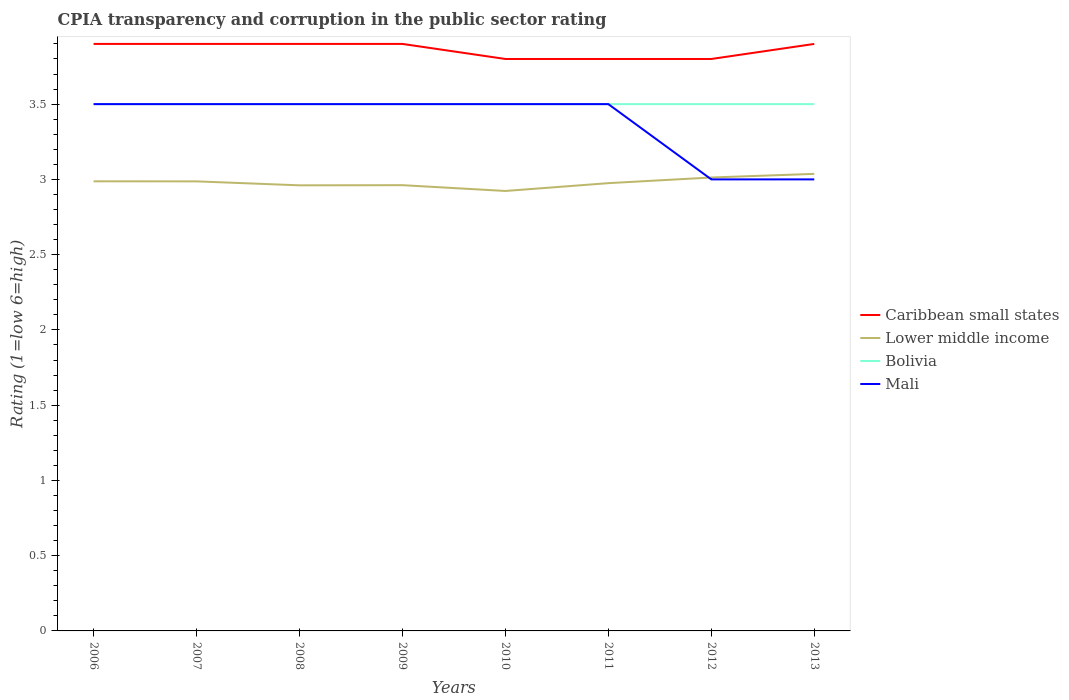How many different coloured lines are there?
Provide a short and direct response. 4. Is the CPIA rating in Mali strictly greater than the CPIA rating in Bolivia over the years?
Give a very brief answer. No. How many lines are there?
Provide a short and direct response. 4. Are the values on the major ticks of Y-axis written in scientific E-notation?
Offer a terse response. No. Does the graph contain any zero values?
Your answer should be very brief. No. Where does the legend appear in the graph?
Offer a very short reply. Center right. How many legend labels are there?
Keep it short and to the point. 4. How are the legend labels stacked?
Provide a short and direct response. Vertical. What is the title of the graph?
Provide a short and direct response. CPIA transparency and corruption in the public sector rating. Does "Papua New Guinea" appear as one of the legend labels in the graph?
Make the answer very short. No. What is the Rating (1=low 6=high) of Lower middle income in 2006?
Keep it short and to the point. 2.99. What is the Rating (1=low 6=high) of Mali in 2006?
Give a very brief answer. 3.5. What is the Rating (1=low 6=high) of Caribbean small states in 2007?
Offer a terse response. 3.9. What is the Rating (1=low 6=high) of Lower middle income in 2007?
Offer a terse response. 2.99. What is the Rating (1=low 6=high) of Bolivia in 2007?
Your response must be concise. 3.5. What is the Rating (1=low 6=high) in Caribbean small states in 2008?
Provide a succinct answer. 3.9. What is the Rating (1=low 6=high) of Lower middle income in 2008?
Offer a terse response. 2.96. What is the Rating (1=low 6=high) of Bolivia in 2008?
Your answer should be compact. 3.5. What is the Rating (1=low 6=high) in Caribbean small states in 2009?
Your answer should be compact. 3.9. What is the Rating (1=low 6=high) of Lower middle income in 2009?
Provide a short and direct response. 2.96. What is the Rating (1=low 6=high) in Bolivia in 2009?
Keep it short and to the point. 3.5. What is the Rating (1=low 6=high) in Lower middle income in 2010?
Your answer should be very brief. 2.92. What is the Rating (1=low 6=high) of Mali in 2010?
Provide a short and direct response. 3.5. What is the Rating (1=low 6=high) of Lower middle income in 2011?
Offer a terse response. 2.98. What is the Rating (1=low 6=high) of Bolivia in 2011?
Your answer should be compact. 3.5. What is the Rating (1=low 6=high) in Lower middle income in 2012?
Make the answer very short. 3.01. What is the Rating (1=low 6=high) of Bolivia in 2012?
Your answer should be compact. 3.5. What is the Rating (1=low 6=high) in Lower middle income in 2013?
Offer a very short reply. 3.04. What is the Rating (1=low 6=high) in Mali in 2013?
Provide a succinct answer. 3. Across all years, what is the maximum Rating (1=low 6=high) in Lower middle income?
Your answer should be very brief. 3.04. Across all years, what is the maximum Rating (1=low 6=high) of Bolivia?
Offer a very short reply. 3.5. Across all years, what is the minimum Rating (1=low 6=high) of Caribbean small states?
Provide a short and direct response. 3.8. Across all years, what is the minimum Rating (1=low 6=high) of Lower middle income?
Keep it short and to the point. 2.92. Across all years, what is the minimum Rating (1=low 6=high) in Mali?
Offer a very short reply. 3. What is the total Rating (1=low 6=high) of Caribbean small states in the graph?
Your answer should be very brief. 30.9. What is the total Rating (1=low 6=high) in Lower middle income in the graph?
Your response must be concise. 23.84. What is the difference between the Rating (1=low 6=high) of Caribbean small states in 2006 and that in 2007?
Give a very brief answer. 0. What is the difference between the Rating (1=low 6=high) of Lower middle income in 2006 and that in 2008?
Make the answer very short. 0.03. What is the difference between the Rating (1=low 6=high) in Caribbean small states in 2006 and that in 2009?
Your answer should be compact. 0. What is the difference between the Rating (1=low 6=high) of Lower middle income in 2006 and that in 2009?
Your answer should be compact. 0.03. What is the difference between the Rating (1=low 6=high) of Lower middle income in 2006 and that in 2010?
Offer a terse response. 0.06. What is the difference between the Rating (1=low 6=high) in Bolivia in 2006 and that in 2010?
Make the answer very short. 0. What is the difference between the Rating (1=low 6=high) in Mali in 2006 and that in 2010?
Keep it short and to the point. 0. What is the difference between the Rating (1=low 6=high) in Caribbean small states in 2006 and that in 2011?
Ensure brevity in your answer.  0.1. What is the difference between the Rating (1=low 6=high) of Lower middle income in 2006 and that in 2011?
Make the answer very short. 0.01. What is the difference between the Rating (1=low 6=high) of Lower middle income in 2006 and that in 2012?
Ensure brevity in your answer.  -0.03. What is the difference between the Rating (1=low 6=high) in Bolivia in 2006 and that in 2012?
Make the answer very short. 0. What is the difference between the Rating (1=low 6=high) of Lower middle income in 2006 and that in 2013?
Give a very brief answer. -0.05. What is the difference between the Rating (1=low 6=high) of Bolivia in 2006 and that in 2013?
Keep it short and to the point. 0. What is the difference between the Rating (1=low 6=high) of Mali in 2006 and that in 2013?
Offer a very short reply. 0.5. What is the difference between the Rating (1=low 6=high) of Caribbean small states in 2007 and that in 2008?
Give a very brief answer. 0. What is the difference between the Rating (1=low 6=high) in Lower middle income in 2007 and that in 2008?
Your answer should be very brief. 0.03. What is the difference between the Rating (1=low 6=high) in Bolivia in 2007 and that in 2008?
Your answer should be very brief. 0. What is the difference between the Rating (1=low 6=high) in Mali in 2007 and that in 2008?
Ensure brevity in your answer.  0. What is the difference between the Rating (1=low 6=high) in Lower middle income in 2007 and that in 2009?
Your answer should be compact. 0.03. What is the difference between the Rating (1=low 6=high) of Lower middle income in 2007 and that in 2010?
Keep it short and to the point. 0.06. What is the difference between the Rating (1=low 6=high) in Lower middle income in 2007 and that in 2011?
Provide a short and direct response. 0.01. What is the difference between the Rating (1=low 6=high) in Bolivia in 2007 and that in 2011?
Provide a short and direct response. 0. What is the difference between the Rating (1=low 6=high) in Mali in 2007 and that in 2011?
Ensure brevity in your answer.  0. What is the difference between the Rating (1=low 6=high) in Caribbean small states in 2007 and that in 2012?
Make the answer very short. 0.1. What is the difference between the Rating (1=low 6=high) of Lower middle income in 2007 and that in 2012?
Make the answer very short. -0.03. What is the difference between the Rating (1=low 6=high) of Bolivia in 2007 and that in 2012?
Provide a short and direct response. 0. What is the difference between the Rating (1=low 6=high) in Mali in 2007 and that in 2012?
Ensure brevity in your answer.  0.5. What is the difference between the Rating (1=low 6=high) of Lower middle income in 2007 and that in 2013?
Your answer should be very brief. -0.05. What is the difference between the Rating (1=low 6=high) in Lower middle income in 2008 and that in 2009?
Your answer should be compact. -0. What is the difference between the Rating (1=low 6=high) of Bolivia in 2008 and that in 2009?
Your answer should be compact. 0. What is the difference between the Rating (1=low 6=high) of Mali in 2008 and that in 2009?
Offer a terse response. 0. What is the difference between the Rating (1=low 6=high) in Caribbean small states in 2008 and that in 2010?
Provide a succinct answer. 0.1. What is the difference between the Rating (1=low 6=high) of Lower middle income in 2008 and that in 2010?
Offer a very short reply. 0.04. What is the difference between the Rating (1=low 6=high) of Bolivia in 2008 and that in 2010?
Your response must be concise. 0. What is the difference between the Rating (1=low 6=high) in Lower middle income in 2008 and that in 2011?
Offer a very short reply. -0.01. What is the difference between the Rating (1=low 6=high) in Caribbean small states in 2008 and that in 2012?
Make the answer very short. 0.1. What is the difference between the Rating (1=low 6=high) in Lower middle income in 2008 and that in 2012?
Ensure brevity in your answer.  -0.05. What is the difference between the Rating (1=low 6=high) of Mali in 2008 and that in 2012?
Your answer should be compact. 0.5. What is the difference between the Rating (1=low 6=high) of Caribbean small states in 2008 and that in 2013?
Keep it short and to the point. 0. What is the difference between the Rating (1=low 6=high) in Lower middle income in 2008 and that in 2013?
Provide a short and direct response. -0.08. What is the difference between the Rating (1=low 6=high) of Mali in 2008 and that in 2013?
Keep it short and to the point. 0.5. What is the difference between the Rating (1=low 6=high) in Lower middle income in 2009 and that in 2010?
Your answer should be compact. 0.04. What is the difference between the Rating (1=low 6=high) in Caribbean small states in 2009 and that in 2011?
Give a very brief answer. 0.1. What is the difference between the Rating (1=low 6=high) of Lower middle income in 2009 and that in 2011?
Your answer should be very brief. -0.01. What is the difference between the Rating (1=low 6=high) in Bolivia in 2009 and that in 2011?
Provide a succinct answer. 0. What is the difference between the Rating (1=low 6=high) in Mali in 2009 and that in 2011?
Your response must be concise. 0. What is the difference between the Rating (1=low 6=high) of Lower middle income in 2009 and that in 2012?
Your answer should be compact. -0.05. What is the difference between the Rating (1=low 6=high) of Bolivia in 2009 and that in 2012?
Your answer should be compact. 0. What is the difference between the Rating (1=low 6=high) of Caribbean small states in 2009 and that in 2013?
Your answer should be very brief. 0. What is the difference between the Rating (1=low 6=high) of Lower middle income in 2009 and that in 2013?
Give a very brief answer. -0.07. What is the difference between the Rating (1=low 6=high) of Bolivia in 2009 and that in 2013?
Provide a short and direct response. 0. What is the difference between the Rating (1=low 6=high) in Mali in 2009 and that in 2013?
Your response must be concise. 0.5. What is the difference between the Rating (1=low 6=high) in Caribbean small states in 2010 and that in 2011?
Your answer should be very brief. 0. What is the difference between the Rating (1=low 6=high) of Lower middle income in 2010 and that in 2011?
Your response must be concise. -0.05. What is the difference between the Rating (1=low 6=high) in Bolivia in 2010 and that in 2011?
Your answer should be compact. 0. What is the difference between the Rating (1=low 6=high) in Lower middle income in 2010 and that in 2012?
Offer a terse response. -0.09. What is the difference between the Rating (1=low 6=high) of Bolivia in 2010 and that in 2012?
Make the answer very short. 0. What is the difference between the Rating (1=low 6=high) in Lower middle income in 2010 and that in 2013?
Provide a short and direct response. -0.11. What is the difference between the Rating (1=low 6=high) in Mali in 2010 and that in 2013?
Give a very brief answer. 0.5. What is the difference between the Rating (1=low 6=high) in Caribbean small states in 2011 and that in 2012?
Make the answer very short. 0. What is the difference between the Rating (1=low 6=high) in Lower middle income in 2011 and that in 2012?
Provide a short and direct response. -0.04. What is the difference between the Rating (1=low 6=high) of Bolivia in 2011 and that in 2012?
Provide a succinct answer. 0. What is the difference between the Rating (1=low 6=high) of Lower middle income in 2011 and that in 2013?
Ensure brevity in your answer.  -0.06. What is the difference between the Rating (1=low 6=high) in Caribbean small states in 2012 and that in 2013?
Your response must be concise. -0.1. What is the difference between the Rating (1=low 6=high) of Lower middle income in 2012 and that in 2013?
Make the answer very short. -0.02. What is the difference between the Rating (1=low 6=high) in Mali in 2012 and that in 2013?
Your answer should be compact. 0. What is the difference between the Rating (1=low 6=high) of Caribbean small states in 2006 and the Rating (1=low 6=high) of Lower middle income in 2007?
Make the answer very short. 0.91. What is the difference between the Rating (1=low 6=high) of Caribbean small states in 2006 and the Rating (1=low 6=high) of Bolivia in 2007?
Offer a terse response. 0.4. What is the difference between the Rating (1=low 6=high) of Lower middle income in 2006 and the Rating (1=low 6=high) of Bolivia in 2007?
Your answer should be very brief. -0.51. What is the difference between the Rating (1=low 6=high) in Lower middle income in 2006 and the Rating (1=low 6=high) in Mali in 2007?
Make the answer very short. -0.51. What is the difference between the Rating (1=low 6=high) of Bolivia in 2006 and the Rating (1=low 6=high) of Mali in 2007?
Make the answer very short. 0. What is the difference between the Rating (1=low 6=high) of Caribbean small states in 2006 and the Rating (1=low 6=high) of Lower middle income in 2008?
Your answer should be very brief. 0.94. What is the difference between the Rating (1=low 6=high) in Lower middle income in 2006 and the Rating (1=low 6=high) in Bolivia in 2008?
Provide a succinct answer. -0.51. What is the difference between the Rating (1=low 6=high) of Lower middle income in 2006 and the Rating (1=low 6=high) of Mali in 2008?
Your response must be concise. -0.51. What is the difference between the Rating (1=low 6=high) in Bolivia in 2006 and the Rating (1=low 6=high) in Mali in 2008?
Offer a terse response. 0. What is the difference between the Rating (1=low 6=high) of Caribbean small states in 2006 and the Rating (1=low 6=high) of Lower middle income in 2009?
Offer a terse response. 0.94. What is the difference between the Rating (1=low 6=high) of Caribbean small states in 2006 and the Rating (1=low 6=high) of Mali in 2009?
Keep it short and to the point. 0.4. What is the difference between the Rating (1=low 6=high) of Lower middle income in 2006 and the Rating (1=low 6=high) of Bolivia in 2009?
Offer a terse response. -0.51. What is the difference between the Rating (1=low 6=high) of Lower middle income in 2006 and the Rating (1=low 6=high) of Mali in 2009?
Offer a terse response. -0.51. What is the difference between the Rating (1=low 6=high) of Bolivia in 2006 and the Rating (1=low 6=high) of Mali in 2009?
Make the answer very short. 0. What is the difference between the Rating (1=low 6=high) of Caribbean small states in 2006 and the Rating (1=low 6=high) of Lower middle income in 2010?
Your response must be concise. 0.98. What is the difference between the Rating (1=low 6=high) in Lower middle income in 2006 and the Rating (1=low 6=high) in Bolivia in 2010?
Offer a terse response. -0.51. What is the difference between the Rating (1=low 6=high) of Lower middle income in 2006 and the Rating (1=low 6=high) of Mali in 2010?
Provide a short and direct response. -0.51. What is the difference between the Rating (1=low 6=high) in Bolivia in 2006 and the Rating (1=low 6=high) in Mali in 2010?
Keep it short and to the point. 0. What is the difference between the Rating (1=low 6=high) of Caribbean small states in 2006 and the Rating (1=low 6=high) of Lower middle income in 2011?
Make the answer very short. 0.93. What is the difference between the Rating (1=low 6=high) in Caribbean small states in 2006 and the Rating (1=low 6=high) in Bolivia in 2011?
Your answer should be very brief. 0.4. What is the difference between the Rating (1=low 6=high) of Lower middle income in 2006 and the Rating (1=low 6=high) of Bolivia in 2011?
Make the answer very short. -0.51. What is the difference between the Rating (1=low 6=high) in Lower middle income in 2006 and the Rating (1=low 6=high) in Mali in 2011?
Offer a very short reply. -0.51. What is the difference between the Rating (1=low 6=high) of Caribbean small states in 2006 and the Rating (1=low 6=high) of Lower middle income in 2012?
Your answer should be very brief. 0.89. What is the difference between the Rating (1=low 6=high) in Caribbean small states in 2006 and the Rating (1=low 6=high) in Bolivia in 2012?
Your answer should be compact. 0.4. What is the difference between the Rating (1=low 6=high) in Lower middle income in 2006 and the Rating (1=low 6=high) in Bolivia in 2012?
Offer a terse response. -0.51. What is the difference between the Rating (1=low 6=high) in Lower middle income in 2006 and the Rating (1=low 6=high) in Mali in 2012?
Provide a short and direct response. -0.01. What is the difference between the Rating (1=low 6=high) of Bolivia in 2006 and the Rating (1=low 6=high) of Mali in 2012?
Provide a short and direct response. 0.5. What is the difference between the Rating (1=low 6=high) of Caribbean small states in 2006 and the Rating (1=low 6=high) of Lower middle income in 2013?
Offer a very short reply. 0.86. What is the difference between the Rating (1=low 6=high) of Caribbean small states in 2006 and the Rating (1=low 6=high) of Bolivia in 2013?
Give a very brief answer. 0.4. What is the difference between the Rating (1=low 6=high) of Lower middle income in 2006 and the Rating (1=low 6=high) of Bolivia in 2013?
Provide a succinct answer. -0.51. What is the difference between the Rating (1=low 6=high) of Lower middle income in 2006 and the Rating (1=low 6=high) of Mali in 2013?
Provide a short and direct response. -0.01. What is the difference between the Rating (1=low 6=high) of Caribbean small states in 2007 and the Rating (1=low 6=high) of Lower middle income in 2008?
Provide a short and direct response. 0.94. What is the difference between the Rating (1=low 6=high) in Caribbean small states in 2007 and the Rating (1=low 6=high) in Bolivia in 2008?
Provide a short and direct response. 0.4. What is the difference between the Rating (1=low 6=high) of Lower middle income in 2007 and the Rating (1=low 6=high) of Bolivia in 2008?
Give a very brief answer. -0.51. What is the difference between the Rating (1=low 6=high) in Lower middle income in 2007 and the Rating (1=low 6=high) in Mali in 2008?
Ensure brevity in your answer.  -0.51. What is the difference between the Rating (1=low 6=high) of Caribbean small states in 2007 and the Rating (1=low 6=high) of Lower middle income in 2009?
Your response must be concise. 0.94. What is the difference between the Rating (1=low 6=high) in Caribbean small states in 2007 and the Rating (1=low 6=high) in Mali in 2009?
Offer a very short reply. 0.4. What is the difference between the Rating (1=low 6=high) of Lower middle income in 2007 and the Rating (1=low 6=high) of Bolivia in 2009?
Offer a terse response. -0.51. What is the difference between the Rating (1=low 6=high) of Lower middle income in 2007 and the Rating (1=low 6=high) of Mali in 2009?
Make the answer very short. -0.51. What is the difference between the Rating (1=low 6=high) in Caribbean small states in 2007 and the Rating (1=low 6=high) in Lower middle income in 2010?
Ensure brevity in your answer.  0.98. What is the difference between the Rating (1=low 6=high) in Caribbean small states in 2007 and the Rating (1=low 6=high) in Bolivia in 2010?
Your answer should be very brief. 0.4. What is the difference between the Rating (1=low 6=high) of Caribbean small states in 2007 and the Rating (1=low 6=high) of Mali in 2010?
Keep it short and to the point. 0.4. What is the difference between the Rating (1=low 6=high) in Lower middle income in 2007 and the Rating (1=low 6=high) in Bolivia in 2010?
Your response must be concise. -0.51. What is the difference between the Rating (1=low 6=high) of Lower middle income in 2007 and the Rating (1=low 6=high) of Mali in 2010?
Give a very brief answer. -0.51. What is the difference between the Rating (1=low 6=high) of Caribbean small states in 2007 and the Rating (1=low 6=high) of Lower middle income in 2011?
Give a very brief answer. 0.93. What is the difference between the Rating (1=low 6=high) of Caribbean small states in 2007 and the Rating (1=low 6=high) of Mali in 2011?
Offer a terse response. 0.4. What is the difference between the Rating (1=low 6=high) in Lower middle income in 2007 and the Rating (1=low 6=high) in Bolivia in 2011?
Your response must be concise. -0.51. What is the difference between the Rating (1=low 6=high) in Lower middle income in 2007 and the Rating (1=low 6=high) in Mali in 2011?
Your answer should be compact. -0.51. What is the difference between the Rating (1=low 6=high) of Caribbean small states in 2007 and the Rating (1=low 6=high) of Lower middle income in 2012?
Your answer should be very brief. 0.89. What is the difference between the Rating (1=low 6=high) of Lower middle income in 2007 and the Rating (1=low 6=high) of Bolivia in 2012?
Offer a terse response. -0.51. What is the difference between the Rating (1=low 6=high) in Lower middle income in 2007 and the Rating (1=low 6=high) in Mali in 2012?
Provide a short and direct response. -0.01. What is the difference between the Rating (1=low 6=high) in Bolivia in 2007 and the Rating (1=low 6=high) in Mali in 2012?
Ensure brevity in your answer.  0.5. What is the difference between the Rating (1=low 6=high) of Caribbean small states in 2007 and the Rating (1=low 6=high) of Lower middle income in 2013?
Offer a terse response. 0.86. What is the difference between the Rating (1=low 6=high) in Caribbean small states in 2007 and the Rating (1=low 6=high) in Bolivia in 2013?
Make the answer very short. 0.4. What is the difference between the Rating (1=low 6=high) of Caribbean small states in 2007 and the Rating (1=low 6=high) of Mali in 2013?
Ensure brevity in your answer.  0.9. What is the difference between the Rating (1=low 6=high) in Lower middle income in 2007 and the Rating (1=low 6=high) in Bolivia in 2013?
Provide a short and direct response. -0.51. What is the difference between the Rating (1=low 6=high) in Lower middle income in 2007 and the Rating (1=low 6=high) in Mali in 2013?
Offer a terse response. -0.01. What is the difference between the Rating (1=low 6=high) of Caribbean small states in 2008 and the Rating (1=low 6=high) of Lower middle income in 2009?
Provide a succinct answer. 0.94. What is the difference between the Rating (1=low 6=high) in Caribbean small states in 2008 and the Rating (1=low 6=high) in Bolivia in 2009?
Give a very brief answer. 0.4. What is the difference between the Rating (1=low 6=high) of Lower middle income in 2008 and the Rating (1=low 6=high) of Bolivia in 2009?
Give a very brief answer. -0.54. What is the difference between the Rating (1=low 6=high) of Lower middle income in 2008 and the Rating (1=low 6=high) of Mali in 2009?
Offer a terse response. -0.54. What is the difference between the Rating (1=low 6=high) in Caribbean small states in 2008 and the Rating (1=low 6=high) in Lower middle income in 2010?
Your response must be concise. 0.98. What is the difference between the Rating (1=low 6=high) of Caribbean small states in 2008 and the Rating (1=low 6=high) of Bolivia in 2010?
Your response must be concise. 0.4. What is the difference between the Rating (1=low 6=high) in Lower middle income in 2008 and the Rating (1=low 6=high) in Bolivia in 2010?
Provide a succinct answer. -0.54. What is the difference between the Rating (1=low 6=high) in Lower middle income in 2008 and the Rating (1=low 6=high) in Mali in 2010?
Your response must be concise. -0.54. What is the difference between the Rating (1=low 6=high) in Caribbean small states in 2008 and the Rating (1=low 6=high) in Lower middle income in 2011?
Keep it short and to the point. 0.93. What is the difference between the Rating (1=low 6=high) of Lower middle income in 2008 and the Rating (1=low 6=high) of Bolivia in 2011?
Provide a short and direct response. -0.54. What is the difference between the Rating (1=low 6=high) of Lower middle income in 2008 and the Rating (1=low 6=high) of Mali in 2011?
Offer a terse response. -0.54. What is the difference between the Rating (1=low 6=high) in Bolivia in 2008 and the Rating (1=low 6=high) in Mali in 2011?
Your answer should be compact. 0. What is the difference between the Rating (1=low 6=high) of Caribbean small states in 2008 and the Rating (1=low 6=high) of Lower middle income in 2012?
Provide a short and direct response. 0.89. What is the difference between the Rating (1=low 6=high) in Caribbean small states in 2008 and the Rating (1=low 6=high) in Bolivia in 2012?
Keep it short and to the point. 0.4. What is the difference between the Rating (1=low 6=high) of Lower middle income in 2008 and the Rating (1=low 6=high) of Bolivia in 2012?
Your answer should be very brief. -0.54. What is the difference between the Rating (1=low 6=high) of Lower middle income in 2008 and the Rating (1=low 6=high) of Mali in 2012?
Your response must be concise. -0.04. What is the difference between the Rating (1=low 6=high) of Bolivia in 2008 and the Rating (1=low 6=high) of Mali in 2012?
Offer a very short reply. 0.5. What is the difference between the Rating (1=low 6=high) in Caribbean small states in 2008 and the Rating (1=low 6=high) in Lower middle income in 2013?
Your response must be concise. 0.86. What is the difference between the Rating (1=low 6=high) of Caribbean small states in 2008 and the Rating (1=low 6=high) of Bolivia in 2013?
Provide a short and direct response. 0.4. What is the difference between the Rating (1=low 6=high) in Caribbean small states in 2008 and the Rating (1=low 6=high) in Mali in 2013?
Give a very brief answer. 0.9. What is the difference between the Rating (1=low 6=high) of Lower middle income in 2008 and the Rating (1=low 6=high) of Bolivia in 2013?
Provide a succinct answer. -0.54. What is the difference between the Rating (1=low 6=high) of Lower middle income in 2008 and the Rating (1=low 6=high) of Mali in 2013?
Provide a short and direct response. -0.04. What is the difference between the Rating (1=low 6=high) in Bolivia in 2008 and the Rating (1=low 6=high) in Mali in 2013?
Offer a terse response. 0.5. What is the difference between the Rating (1=low 6=high) in Caribbean small states in 2009 and the Rating (1=low 6=high) in Lower middle income in 2010?
Provide a succinct answer. 0.98. What is the difference between the Rating (1=low 6=high) of Caribbean small states in 2009 and the Rating (1=low 6=high) of Mali in 2010?
Provide a short and direct response. 0.4. What is the difference between the Rating (1=low 6=high) of Lower middle income in 2009 and the Rating (1=low 6=high) of Bolivia in 2010?
Offer a terse response. -0.54. What is the difference between the Rating (1=low 6=high) in Lower middle income in 2009 and the Rating (1=low 6=high) in Mali in 2010?
Provide a succinct answer. -0.54. What is the difference between the Rating (1=low 6=high) in Bolivia in 2009 and the Rating (1=low 6=high) in Mali in 2010?
Provide a short and direct response. 0. What is the difference between the Rating (1=low 6=high) in Caribbean small states in 2009 and the Rating (1=low 6=high) in Lower middle income in 2011?
Your answer should be very brief. 0.93. What is the difference between the Rating (1=low 6=high) of Caribbean small states in 2009 and the Rating (1=low 6=high) of Mali in 2011?
Your answer should be compact. 0.4. What is the difference between the Rating (1=low 6=high) in Lower middle income in 2009 and the Rating (1=low 6=high) in Bolivia in 2011?
Make the answer very short. -0.54. What is the difference between the Rating (1=low 6=high) of Lower middle income in 2009 and the Rating (1=low 6=high) of Mali in 2011?
Ensure brevity in your answer.  -0.54. What is the difference between the Rating (1=low 6=high) of Caribbean small states in 2009 and the Rating (1=low 6=high) of Lower middle income in 2012?
Offer a very short reply. 0.89. What is the difference between the Rating (1=low 6=high) of Caribbean small states in 2009 and the Rating (1=low 6=high) of Bolivia in 2012?
Give a very brief answer. 0.4. What is the difference between the Rating (1=low 6=high) of Caribbean small states in 2009 and the Rating (1=low 6=high) of Mali in 2012?
Make the answer very short. 0.9. What is the difference between the Rating (1=low 6=high) of Lower middle income in 2009 and the Rating (1=low 6=high) of Bolivia in 2012?
Offer a very short reply. -0.54. What is the difference between the Rating (1=low 6=high) in Lower middle income in 2009 and the Rating (1=low 6=high) in Mali in 2012?
Give a very brief answer. -0.04. What is the difference between the Rating (1=low 6=high) in Bolivia in 2009 and the Rating (1=low 6=high) in Mali in 2012?
Provide a succinct answer. 0.5. What is the difference between the Rating (1=low 6=high) in Caribbean small states in 2009 and the Rating (1=low 6=high) in Lower middle income in 2013?
Keep it short and to the point. 0.86. What is the difference between the Rating (1=low 6=high) of Caribbean small states in 2009 and the Rating (1=low 6=high) of Bolivia in 2013?
Offer a terse response. 0.4. What is the difference between the Rating (1=low 6=high) of Lower middle income in 2009 and the Rating (1=low 6=high) of Bolivia in 2013?
Keep it short and to the point. -0.54. What is the difference between the Rating (1=low 6=high) in Lower middle income in 2009 and the Rating (1=low 6=high) in Mali in 2013?
Offer a very short reply. -0.04. What is the difference between the Rating (1=low 6=high) in Bolivia in 2009 and the Rating (1=low 6=high) in Mali in 2013?
Provide a short and direct response. 0.5. What is the difference between the Rating (1=low 6=high) of Caribbean small states in 2010 and the Rating (1=low 6=high) of Lower middle income in 2011?
Make the answer very short. 0.82. What is the difference between the Rating (1=low 6=high) of Caribbean small states in 2010 and the Rating (1=low 6=high) of Bolivia in 2011?
Offer a very short reply. 0.3. What is the difference between the Rating (1=low 6=high) of Lower middle income in 2010 and the Rating (1=low 6=high) of Bolivia in 2011?
Give a very brief answer. -0.58. What is the difference between the Rating (1=low 6=high) in Lower middle income in 2010 and the Rating (1=low 6=high) in Mali in 2011?
Your answer should be very brief. -0.58. What is the difference between the Rating (1=low 6=high) in Bolivia in 2010 and the Rating (1=low 6=high) in Mali in 2011?
Provide a short and direct response. 0. What is the difference between the Rating (1=low 6=high) of Caribbean small states in 2010 and the Rating (1=low 6=high) of Lower middle income in 2012?
Your response must be concise. 0.79. What is the difference between the Rating (1=low 6=high) in Caribbean small states in 2010 and the Rating (1=low 6=high) in Bolivia in 2012?
Give a very brief answer. 0.3. What is the difference between the Rating (1=low 6=high) in Caribbean small states in 2010 and the Rating (1=low 6=high) in Mali in 2012?
Make the answer very short. 0.8. What is the difference between the Rating (1=low 6=high) in Lower middle income in 2010 and the Rating (1=low 6=high) in Bolivia in 2012?
Offer a very short reply. -0.58. What is the difference between the Rating (1=low 6=high) of Lower middle income in 2010 and the Rating (1=low 6=high) of Mali in 2012?
Offer a terse response. -0.08. What is the difference between the Rating (1=low 6=high) in Caribbean small states in 2010 and the Rating (1=low 6=high) in Lower middle income in 2013?
Your answer should be very brief. 0.76. What is the difference between the Rating (1=low 6=high) in Lower middle income in 2010 and the Rating (1=low 6=high) in Bolivia in 2013?
Provide a succinct answer. -0.58. What is the difference between the Rating (1=low 6=high) in Lower middle income in 2010 and the Rating (1=low 6=high) in Mali in 2013?
Your answer should be very brief. -0.08. What is the difference between the Rating (1=low 6=high) in Bolivia in 2010 and the Rating (1=low 6=high) in Mali in 2013?
Provide a succinct answer. 0.5. What is the difference between the Rating (1=low 6=high) in Caribbean small states in 2011 and the Rating (1=low 6=high) in Lower middle income in 2012?
Keep it short and to the point. 0.79. What is the difference between the Rating (1=low 6=high) in Caribbean small states in 2011 and the Rating (1=low 6=high) in Mali in 2012?
Ensure brevity in your answer.  0.8. What is the difference between the Rating (1=low 6=high) of Lower middle income in 2011 and the Rating (1=low 6=high) of Bolivia in 2012?
Give a very brief answer. -0.53. What is the difference between the Rating (1=low 6=high) of Lower middle income in 2011 and the Rating (1=low 6=high) of Mali in 2012?
Your response must be concise. -0.03. What is the difference between the Rating (1=low 6=high) in Caribbean small states in 2011 and the Rating (1=low 6=high) in Lower middle income in 2013?
Your answer should be compact. 0.76. What is the difference between the Rating (1=low 6=high) in Caribbean small states in 2011 and the Rating (1=low 6=high) in Mali in 2013?
Give a very brief answer. 0.8. What is the difference between the Rating (1=low 6=high) of Lower middle income in 2011 and the Rating (1=low 6=high) of Bolivia in 2013?
Your answer should be very brief. -0.53. What is the difference between the Rating (1=low 6=high) of Lower middle income in 2011 and the Rating (1=low 6=high) of Mali in 2013?
Offer a very short reply. -0.03. What is the difference between the Rating (1=low 6=high) of Bolivia in 2011 and the Rating (1=low 6=high) of Mali in 2013?
Offer a terse response. 0.5. What is the difference between the Rating (1=low 6=high) of Caribbean small states in 2012 and the Rating (1=low 6=high) of Lower middle income in 2013?
Provide a succinct answer. 0.76. What is the difference between the Rating (1=low 6=high) of Caribbean small states in 2012 and the Rating (1=low 6=high) of Bolivia in 2013?
Ensure brevity in your answer.  0.3. What is the difference between the Rating (1=low 6=high) of Lower middle income in 2012 and the Rating (1=low 6=high) of Bolivia in 2013?
Make the answer very short. -0.49. What is the difference between the Rating (1=low 6=high) in Lower middle income in 2012 and the Rating (1=low 6=high) in Mali in 2013?
Give a very brief answer. 0.01. What is the average Rating (1=low 6=high) in Caribbean small states per year?
Provide a short and direct response. 3.86. What is the average Rating (1=low 6=high) of Lower middle income per year?
Your response must be concise. 2.98. What is the average Rating (1=low 6=high) in Mali per year?
Offer a very short reply. 3.38. In the year 2006, what is the difference between the Rating (1=low 6=high) in Caribbean small states and Rating (1=low 6=high) in Lower middle income?
Give a very brief answer. 0.91. In the year 2006, what is the difference between the Rating (1=low 6=high) in Caribbean small states and Rating (1=low 6=high) in Bolivia?
Offer a very short reply. 0.4. In the year 2006, what is the difference between the Rating (1=low 6=high) of Lower middle income and Rating (1=low 6=high) of Bolivia?
Make the answer very short. -0.51. In the year 2006, what is the difference between the Rating (1=low 6=high) in Lower middle income and Rating (1=low 6=high) in Mali?
Provide a succinct answer. -0.51. In the year 2006, what is the difference between the Rating (1=low 6=high) of Bolivia and Rating (1=low 6=high) of Mali?
Your response must be concise. 0. In the year 2007, what is the difference between the Rating (1=low 6=high) of Caribbean small states and Rating (1=low 6=high) of Lower middle income?
Offer a terse response. 0.91. In the year 2007, what is the difference between the Rating (1=low 6=high) in Caribbean small states and Rating (1=low 6=high) in Mali?
Your answer should be very brief. 0.4. In the year 2007, what is the difference between the Rating (1=low 6=high) of Lower middle income and Rating (1=low 6=high) of Bolivia?
Your answer should be compact. -0.51. In the year 2007, what is the difference between the Rating (1=low 6=high) in Lower middle income and Rating (1=low 6=high) in Mali?
Your answer should be very brief. -0.51. In the year 2007, what is the difference between the Rating (1=low 6=high) in Bolivia and Rating (1=low 6=high) in Mali?
Your answer should be very brief. 0. In the year 2008, what is the difference between the Rating (1=low 6=high) in Caribbean small states and Rating (1=low 6=high) in Lower middle income?
Provide a succinct answer. 0.94. In the year 2008, what is the difference between the Rating (1=low 6=high) in Lower middle income and Rating (1=low 6=high) in Bolivia?
Your response must be concise. -0.54. In the year 2008, what is the difference between the Rating (1=low 6=high) of Lower middle income and Rating (1=low 6=high) of Mali?
Make the answer very short. -0.54. In the year 2008, what is the difference between the Rating (1=low 6=high) in Bolivia and Rating (1=low 6=high) in Mali?
Ensure brevity in your answer.  0. In the year 2009, what is the difference between the Rating (1=low 6=high) in Caribbean small states and Rating (1=low 6=high) in Lower middle income?
Your answer should be very brief. 0.94. In the year 2009, what is the difference between the Rating (1=low 6=high) of Lower middle income and Rating (1=low 6=high) of Bolivia?
Give a very brief answer. -0.54. In the year 2009, what is the difference between the Rating (1=low 6=high) of Lower middle income and Rating (1=low 6=high) of Mali?
Give a very brief answer. -0.54. In the year 2009, what is the difference between the Rating (1=low 6=high) in Bolivia and Rating (1=low 6=high) in Mali?
Offer a terse response. 0. In the year 2010, what is the difference between the Rating (1=low 6=high) in Caribbean small states and Rating (1=low 6=high) in Lower middle income?
Give a very brief answer. 0.88. In the year 2010, what is the difference between the Rating (1=low 6=high) in Caribbean small states and Rating (1=low 6=high) in Bolivia?
Offer a very short reply. 0.3. In the year 2010, what is the difference between the Rating (1=low 6=high) in Caribbean small states and Rating (1=low 6=high) in Mali?
Your answer should be very brief. 0.3. In the year 2010, what is the difference between the Rating (1=low 6=high) of Lower middle income and Rating (1=low 6=high) of Bolivia?
Offer a terse response. -0.58. In the year 2010, what is the difference between the Rating (1=low 6=high) in Lower middle income and Rating (1=low 6=high) in Mali?
Offer a very short reply. -0.58. In the year 2010, what is the difference between the Rating (1=low 6=high) of Bolivia and Rating (1=low 6=high) of Mali?
Offer a terse response. 0. In the year 2011, what is the difference between the Rating (1=low 6=high) in Caribbean small states and Rating (1=low 6=high) in Lower middle income?
Your answer should be very brief. 0.82. In the year 2011, what is the difference between the Rating (1=low 6=high) in Caribbean small states and Rating (1=low 6=high) in Bolivia?
Your answer should be very brief. 0.3. In the year 2011, what is the difference between the Rating (1=low 6=high) of Lower middle income and Rating (1=low 6=high) of Bolivia?
Your answer should be very brief. -0.53. In the year 2011, what is the difference between the Rating (1=low 6=high) of Lower middle income and Rating (1=low 6=high) of Mali?
Your response must be concise. -0.53. In the year 2011, what is the difference between the Rating (1=low 6=high) of Bolivia and Rating (1=low 6=high) of Mali?
Keep it short and to the point. 0. In the year 2012, what is the difference between the Rating (1=low 6=high) of Caribbean small states and Rating (1=low 6=high) of Lower middle income?
Your answer should be very brief. 0.79. In the year 2012, what is the difference between the Rating (1=low 6=high) in Caribbean small states and Rating (1=low 6=high) in Bolivia?
Ensure brevity in your answer.  0.3. In the year 2012, what is the difference between the Rating (1=low 6=high) of Lower middle income and Rating (1=low 6=high) of Bolivia?
Make the answer very short. -0.49. In the year 2012, what is the difference between the Rating (1=low 6=high) of Lower middle income and Rating (1=low 6=high) of Mali?
Make the answer very short. 0.01. In the year 2012, what is the difference between the Rating (1=low 6=high) in Bolivia and Rating (1=low 6=high) in Mali?
Offer a terse response. 0.5. In the year 2013, what is the difference between the Rating (1=low 6=high) of Caribbean small states and Rating (1=low 6=high) of Lower middle income?
Make the answer very short. 0.86. In the year 2013, what is the difference between the Rating (1=low 6=high) in Caribbean small states and Rating (1=low 6=high) in Bolivia?
Make the answer very short. 0.4. In the year 2013, what is the difference between the Rating (1=low 6=high) of Caribbean small states and Rating (1=low 6=high) of Mali?
Your response must be concise. 0.9. In the year 2013, what is the difference between the Rating (1=low 6=high) of Lower middle income and Rating (1=low 6=high) of Bolivia?
Make the answer very short. -0.46. In the year 2013, what is the difference between the Rating (1=low 6=high) in Lower middle income and Rating (1=low 6=high) in Mali?
Your response must be concise. 0.04. What is the ratio of the Rating (1=low 6=high) in Bolivia in 2006 to that in 2007?
Keep it short and to the point. 1. What is the ratio of the Rating (1=low 6=high) of Mali in 2006 to that in 2007?
Provide a succinct answer. 1. What is the ratio of the Rating (1=low 6=high) in Lower middle income in 2006 to that in 2008?
Your answer should be very brief. 1.01. What is the ratio of the Rating (1=low 6=high) of Mali in 2006 to that in 2008?
Provide a succinct answer. 1. What is the ratio of the Rating (1=low 6=high) of Caribbean small states in 2006 to that in 2009?
Your answer should be very brief. 1. What is the ratio of the Rating (1=low 6=high) in Lower middle income in 2006 to that in 2009?
Provide a succinct answer. 1.01. What is the ratio of the Rating (1=low 6=high) of Bolivia in 2006 to that in 2009?
Provide a succinct answer. 1. What is the ratio of the Rating (1=low 6=high) in Mali in 2006 to that in 2009?
Offer a terse response. 1. What is the ratio of the Rating (1=low 6=high) in Caribbean small states in 2006 to that in 2010?
Your response must be concise. 1.03. What is the ratio of the Rating (1=low 6=high) in Lower middle income in 2006 to that in 2010?
Your answer should be very brief. 1.02. What is the ratio of the Rating (1=low 6=high) in Caribbean small states in 2006 to that in 2011?
Provide a succinct answer. 1.03. What is the ratio of the Rating (1=low 6=high) in Bolivia in 2006 to that in 2011?
Provide a short and direct response. 1. What is the ratio of the Rating (1=low 6=high) of Mali in 2006 to that in 2011?
Provide a short and direct response. 1. What is the ratio of the Rating (1=low 6=high) in Caribbean small states in 2006 to that in 2012?
Your response must be concise. 1.03. What is the ratio of the Rating (1=low 6=high) in Mali in 2006 to that in 2012?
Your answer should be compact. 1.17. What is the ratio of the Rating (1=low 6=high) in Lower middle income in 2006 to that in 2013?
Offer a very short reply. 0.98. What is the ratio of the Rating (1=low 6=high) in Mali in 2006 to that in 2013?
Offer a terse response. 1.17. What is the ratio of the Rating (1=low 6=high) in Caribbean small states in 2007 to that in 2008?
Offer a very short reply. 1. What is the ratio of the Rating (1=low 6=high) in Lower middle income in 2007 to that in 2008?
Your answer should be compact. 1.01. What is the ratio of the Rating (1=low 6=high) in Caribbean small states in 2007 to that in 2009?
Give a very brief answer. 1. What is the ratio of the Rating (1=low 6=high) in Lower middle income in 2007 to that in 2009?
Offer a terse response. 1.01. What is the ratio of the Rating (1=low 6=high) in Bolivia in 2007 to that in 2009?
Offer a very short reply. 1. What is the ratio of the Rating (1=low 6=high) in Mali in 2007 to that in 2009?
Provide a succinct answer. 1. What is the ratio of the Rating (1=low 6=high) in Caribbean small states in 2007 to that in 2010?
Offer a very short reply. 1.03. What is the ratio of the Rating (1=low 6=high) in Lower middle income in 2007 to that in 2010?
Offer a very short reply. 1.02. What is the ratio of the Rating (1=low 6=high) of Caribbean small states in 2007 to that in 2011?
Your answer should be compact. 1.03. What is the ratio of the Rating (1=low 6=high) in Lower middle income in 2007 to that in 2011?
Your answer should be very brief. 1. What is the ratio of the Rating (1=low 6=high) of Mali in 2007 to that in 2011?
Your answer should be compact. 1. What is the ratio of the Rating (1=low 6=high) of Caribbean small states in 2007 to that in 2012?
Keep it short and to the point. 1.03. What is the ratio of the Rating (1=low 6=high) of Mali in 2007 to that in 2012?
Make the answer very short. 1.17. What is the ratio of the Rating (1=low 6=high) in Caribbean small states in 2007 to that in 2013?
Offer a very short reply. 1. What is the ratio of the Rating (1=low 6=high) of Lower middle income in 2007 to that in 2013?
Provide a short and direct response. 0.98. What is the ratio of the Rating (1=low 6=high) in Mali in 2007 to that in 2013?
Ensure brevity in your answer.  1.17. What is the ratio of the Rating (1=low 6=high) of Caribbean small states in 2008 to that in 2009?
Offer a very short reply. 1. What is the ratio of the Rating (1=low 6=high) of Lower middle income in 2008 to that in 2009?
Offer a terse response. 1. What is the ratio of the Rating (1=low 6=high) of Caribbean small states in 2008 to that in 2010?
Provide a succinct answer. 1.03. What is the ratio of the Rating (1=low 6=high) of Lower middle income in 2008 to that in 2010?
Your response must be concise. 1.01. What is the ratio of the Rating (1=low 6=high) in Caribbean small states in 2008 to that in 2011?
Your answer should be compact. 1.03. What is the ratio of the Rating (1=low 6=high) of Lower middle income in 2008 to that in 2011?
Your response must be concise. 1. What is the ratio of the Rating (1=low 6=high) in Bolivia in 2008 to that in 2011?
Offer a terse response. 1. What is the ratio of the Rating (1=low 6=high) in Mali in 2008 to that in 2011?
Make the answer very short. 1. What is the ratio of the Rating (1=low 6=high) in Caribbean small states in 2008 to that in 2012?
Make the answer very short. 1.03. What is the ratio of the Rating (1=low 6=high) in Lower middle income in 2008 to that in 2012?
Your answer should be compact. 0.98. What is the ratio of the Rating (1=low 6=high) of Caribbean small states in 2008 to that in 2013?
Offer a very short reply. 1. What is the ratio of the Rating (1=low 6=high) of Lower middle income in 2008 to that in 2013?
Offer a terse response. 0.97. What is the ratio of the Rating (1=low 6=high) in Bolivia in 2008 to that in 2013?
Your response must be concise. 1. What is the ratio of the Rating (1=low 6=high) of Caribbean small states in 2009 to that in 2010?
Provide a short and direct response. 1.03. What is the ratio of the Rating (1=low 6=high) in Lower middle income in 2009 to that in 2010?
Ensure brevity in your answer.  1.01. What is the ratio of the Rating (1=low 6=high) in Bolivia in 2009 to that in 2010?
Make the answer very short. 1. What is the ratio of the Rating (1=low 6=high) in Mali in 2009 to that in 2010?
Your answer should be very brief. 1. What is the ratio of the Rating (1=low 6=high) of Caribbean small states in 2009 to that in 2011?
Your answer should be very brief. 1.03. What is the ratio of the Rating (1=low 6=high) of Lower middle income in 2009 to that in 2011?
Your answer should be very brief. 1. What is the ratio of the Rating (1=low 6=high) in Caribbean small states in 2009 to that in 2012?
Keep it short and to the point. 1.03. What is the ratio of the Rating (1=low 6=high) in Lower middle income in 2009 to that in 2012?
Your answer should be very brief. 0.98. What is the ratio of the Rating (1=low 6=high) in Mali in 2009 to that in 2012?
Give a very brief answer. 1.17. What is the ratio of the Rating (1=low 6=high) of Lower middle income in 2009 to that in 2013?
Provide a short and direct response. 0.98. What is the ratio of the Rating (1=low 6=high) in Bolivia in 2009 to that in 2013?
Ensure brevity in your answer.  1. What is the ratio of the Rating (1=low 6=high) in Mali in 2009 to that in 2013?
Keep it short and to the point. 1.17. What is the ratio of the Rating (1=low 6=high) in Caribbean small states in 2010 to that in 2011?
Provide a short and direct response. 1. What is the ratio of the Rating (1=low 6=high) of Lower middle income in 2010 to that in 2011?
Your response must be concise. 0.98. What is the ratio of the Rating (1=low 6=high) of Lower middle income in 2010 to that in 2012?
Provide a short and direct response. 0.97. What is the ratio of the Rating (1=low 6=high) of Bolivia in 2010 to that in 2012?
Provide a short and direct response. 1. What is the ratio of the Rating (1=low 6=high) in Mali in 2010 to that in 2012?
Provide a succinct answer. 1.17. What is the ratio of the Rating (1=low 6=high) of Caribbean small states in 2010 to that in 2013?
Give a very brief answer. 0.97. What is the ratio of the Rating (1=low 6=high) of Lower middle income in 2010 to that in 2013?
Provide a short and direct response. 0.96. What is the ratio of the Rating (1=low 6=high) in Bolivia in 2010 to that in 2013?
Give a very brief answer. 1. What is the ratio of the Rating (1=low 6=high) of Lower middle income in 2011 to that in 2012?
Your answer should be compact. 0.99. What is the ratio of the Rating (1=low 6=high) in Mali in 2011 to that in 2012?
Give a very brief answer. 1.17. What is the ratio of the Rating (1=low 6=high) of Caribbean small states in 2011 to that in 2013?
Your response must be concise. 0.97. What is the ratio of the Rating (1=low 6=high) of Lower middle income in 2011 to that in 2013?
Your answer should be very brief. 0.98. What is the ratio of the Rating (1=low 6=high) in Mali in 2011 to that in 2013?
Your answer should be compact. 1.17. What is the ratio of the Rating (1=low 6=high) in Caribbean small states in 2012 to that in 2013?
Provide a succinct answer. 0.97. What is the ratio of the Rating (1=low 6=high) of Lower middle income in 2012 to that in 2013?
Provide a short and direct response. 0.99. What is the ratio of the Rating (1=low 6=high) in Bolivia in 2012 to that in 2013?
Provide a succinct answer. 1. What is the difference between the highest and the second highest Rating (1=low 6=high) of Caribbean small states?
Offer a very short reply. 0. What is the difference between the highest and the second highest Rating (1=low 6=high) of Lower middle income?
Offer a very short reply. 0.02. What is the difference between the highest and the second highest Rating (1=low 6=high) in Bolivia?
Your answer should be very brief. 0. What is the difference between the highest and the second highest Rating (1=low 6=high) of Mali?
Keep it short and to the point. 0. What is the difference between the highest and the lowest Rating (1=low 6=high) in Lower middle income?
Offer a terse response. 0.11. What is the difference between the highest and the lowest Rating (1=low 6=high) in Bolivia?
Your response must be concise. 0. What is the difference between the highest and the lowest Rating (1=low 6=high) in Mali?
Give a very brief answer. 0.5. 